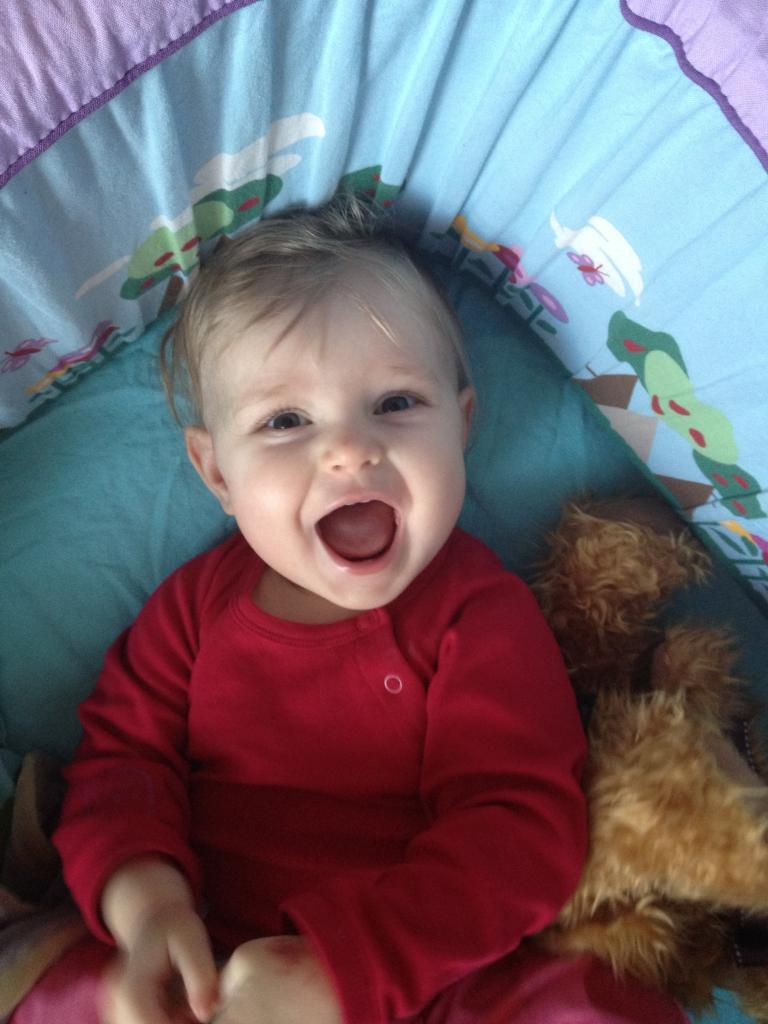What is the main subject of the image? There is a person in the image. What is the person doing in the image? The person is laying on a bed. What expression does the person have in the image? The person is smiling. What type of quarter can be seen in the person's hand in the image? There is no quarter present in the image; the person is laying on a bed and smiling. 